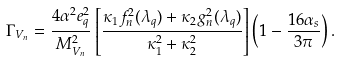<formula> <loc_0><loc_0><loc_500><loc_500>\Gamma _ { V _ { n } } = \frac { 4 \alpha ^ { 2 } e _ { q } ^ { 2 } } { M _ { V _ { n } } ^ { 2 } } \left [ \frac { \kappa _ { 1 } f ^ { 2 } _ { n } ( \lambda _ { q } ) + \kappa _ { 2 } g ^ { 2 } _ { n } ( \lambda _ { q } ) } { \kappa _ { 1 } ^ { 2 } + \kappa _ { 2 } ^ { 2 } } \right ] \left ( 1 - \frac { 1 6 \alpha _ { s } } { 3 \pi } \right ) .</formula> 